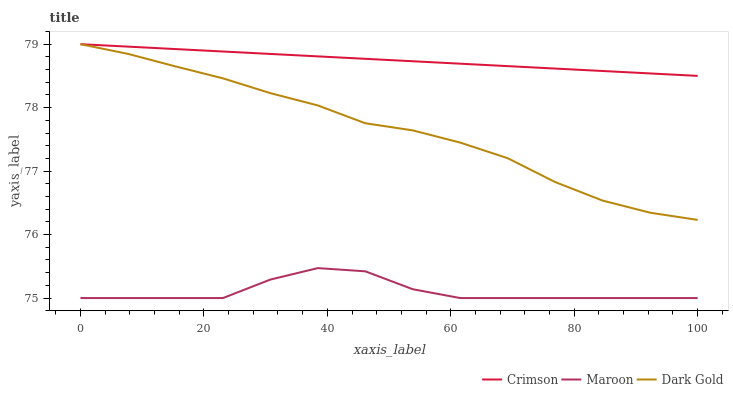Does Maroon have the minimum area under the curve?
Answer yes or no. Yes. Does Dark Gold have the minimum area under the curve?
Answer yes or no. No. Does Dark Gold have the maximum area under the curve?
Answer yes or no. No. Is Dark Gold the smoothest?
Answer yes or no. No. Is Dark Gold the roughest?
Answer yes or no. No. Does Dark Gold have the lowest value?
Answer yes or no. No. Does Maroon have the highest value?
Answer yes or no. No. Is Maroon less than Dark Gold?
Answer yes or no. Yes. Is Dark Gold greater than Maroon?
Answer yes or no. Yes. Does Maroon intersect Dark Gold?
Answer yes or no. No. 